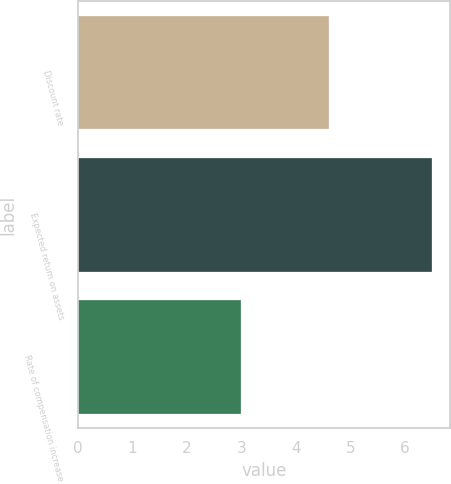Convert chart to OTSL. <chart><loc_0><loc_0><loc_500><loc_500><bar_chart><fcel>Discount rate<fcel>Expected return on assets<fcel>Rate of compensation increase<nl><fcel>4.6<fcel>6.5<fcel>3<nl></chart> 